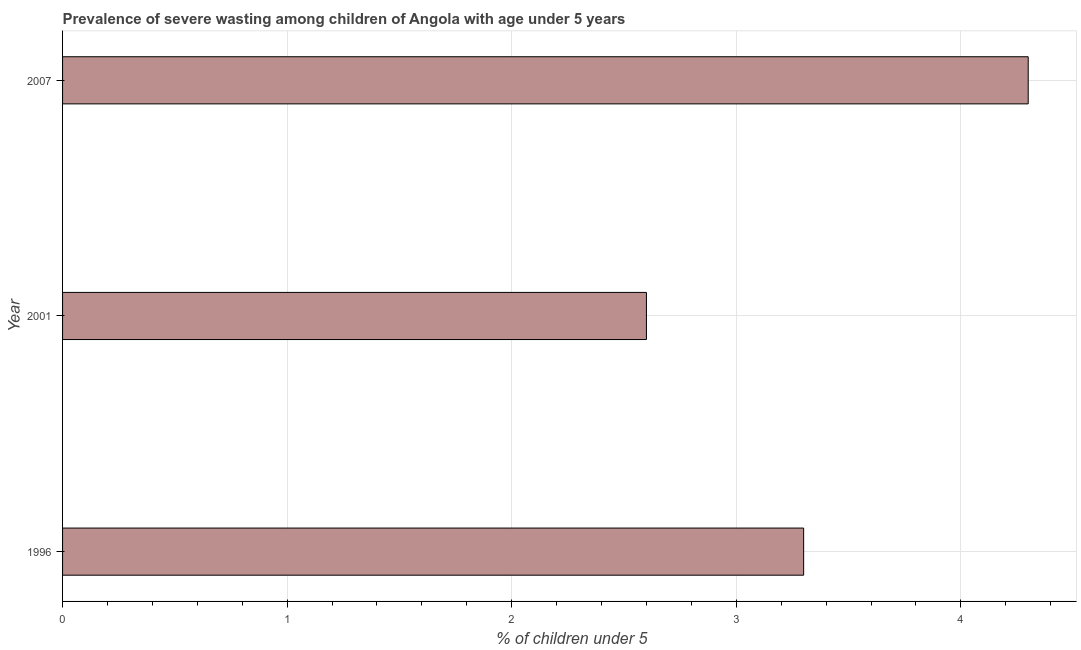What is the title of the graph?
Your response must be concise. Prevalence of severe wasting among children of Angola with age under 5 years. What is the label or title of the X-axis?
Give a very brief answer.  % of children under 5. What is the prevalence of severe wasting in 2007?
Provide a short and direct response. 4.3. Across all years, what is the maximum prevalence of severe wasting?
Offer a very short reply. 4.3. Across all years, what is the minimum prevalence of severe wasting?
Your response must be concise. 2.6. What is the sum of the prevalence of severe wasting?
Keep it short and to the point. 10.2. What is the average prevalence of severe wasting per year?
Offer a very short reply. 3.4. What is the median prevalence of severe wasting?
Ensure brevity in your answer.  3.3. Do a majority of the years between 2007 and 1996 (inclusive) have prevalence of severe wasting greater than 4 %?
Offer a very short reply. Yes. What is the ratio of the prevalence of severe wasting in 1996 to that in 2007?
Provide a short and direct response. 0.77. Is the prevalence of severe wasting in 1996 less than that in 2007?
Provide a succinct answer. Yes. Is the difference between the prevalence of severe wasting in 1996 and 2007 greater than the difference between any two years?
Your answer should be compact. No. What is the difference between the highest and the second highest prevalence of severe wasting?
Your answer should be compact. 1. What is the difference between the highest and the lowest prevalence of severe wasting?
Make the answer very short. 1.7. Are all the bars in the graph horizontal?
Offer a terse response. Yes. How many years are there in the graph?
Give a very brief answer. 3. What is the difference between two consecutive major ticks on the X-axis?
Ensure brevity in your answer.  1. What is the  % of children under 5 of 1996?
Offer a terse response. 3.3. What is the  % of children under 5 in 2001?
Provide a succinct answer. 2.6. What is the  % of children under 5 of 2007?
Your answer should be compact. 4.3. What is the difference between the  % of children under 5 in 1996 and 2007?
Ensure brevity in your answer.  -1. What is the ratio of the  % of children under 5 in 1996 to that in 2001?
Ensure brevity in your answer.  1.27. What is the ratio of the  % of children under 5 in 1996 to that in 2007?
Make the answer very short. 0.77. What is the ratio of the  % of children under 5 in 2001 to that in 2007?
Offer a very short reply. 0.6. 